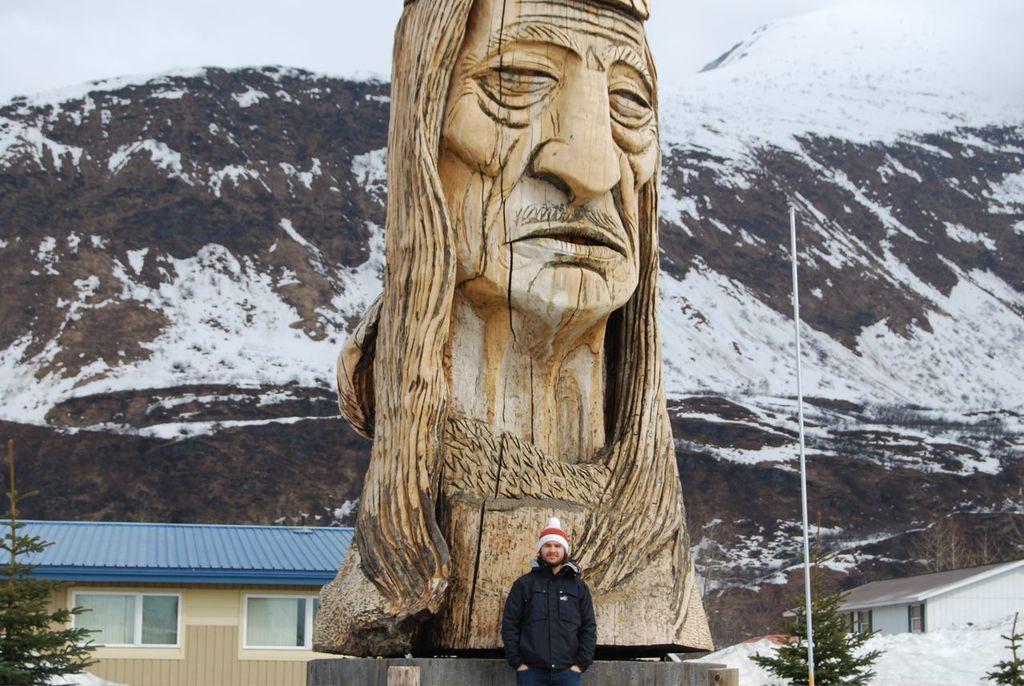Could you give a brief overview of what you see in this image? In this picture there is a person standing at the statue. In this picture there is a wooden statue of a person. At the back there are buildings and trees and there is a mountain. On the right side of the image there is a pole. At the top there is sky. At the bottom there is snow and there is snow on the mountain. 